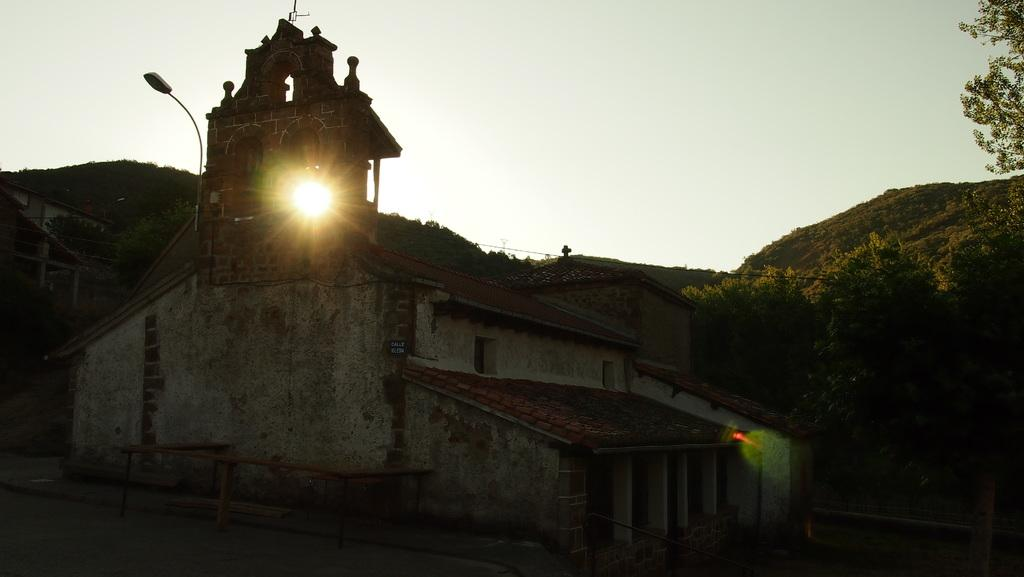What type of structures can be seen in the image? There are buildings in the image. What is the tall, vertical object in the image? There is a light pole in the image. What can be seen in the distance in the image? Hills, trees, and the sky are visible in the background of the image. What type of lipstick is the building wearing in the image? There is no lipstick or indication of cosmetics in the image; it features buildings, a light pole, and a background with hills, trees, and the sky. 